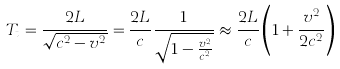<formula> <loc_0><loc_0><loc_500><loc_500>T _ { t } = { \frac { 2 L } { \sqrt { c ^ { 2 } - v ^ { 2 } } } } = { \frac { 2 L } { c } } { \frac { 1 } { \sqrt { 1 - { \frac { v ^ { 2 } } { c ^ { 2 } } } } } } \approx { \frac { 2 L } { c } } \left ( 1 + { \frac { v ^ { 2 } } { 2 c ^ { 2 } } } \right )</formula> 